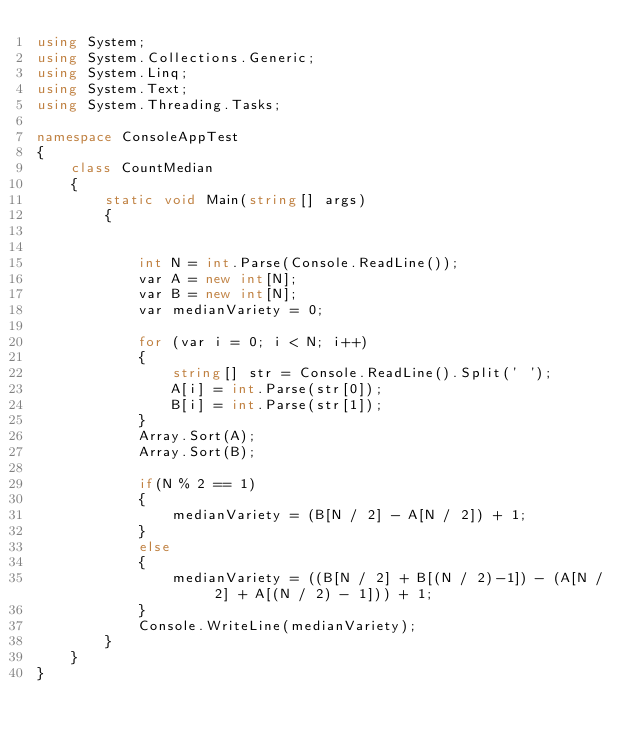Convert code to text. <code><loc_0><loc_0><loc_500><loc_500><_C#_>using System;
using System.Collections.Generic;
using System.Linq;
using System.Text;
using System.Threading.Tasks;

namespace ConsoleAppTest
{
    class CountMedian
    {
        static void Main(string[] args)
        {


            int N = int.Parse(Console.ReadLine());
            var A = new int[N];
            var B = new int[N];
            var medianVariety = 0;

            for (var i = 0; i < N; i++)
            {
                string[] str = Console.ReadLine().Split(' ');
                A[i] = int.Parse(str[0]);
                B[i] = int.Parse(str[1]);
            }
            Array.Sort(A);
            Array.Sort(B);

            if(N % 2 == 1)
            {
                medianVariety = (B[N / 2] - A[N / 2]) + 1;
            }
            else
            {
                medianVariety = ((B[N / 2] + B[(N / 2)-1]) - (A[N / 2] + A[(N / 2) - 1])) + 1;
            }
            Console.WriteLine(medianVariety);
        }
    }
}</code> 